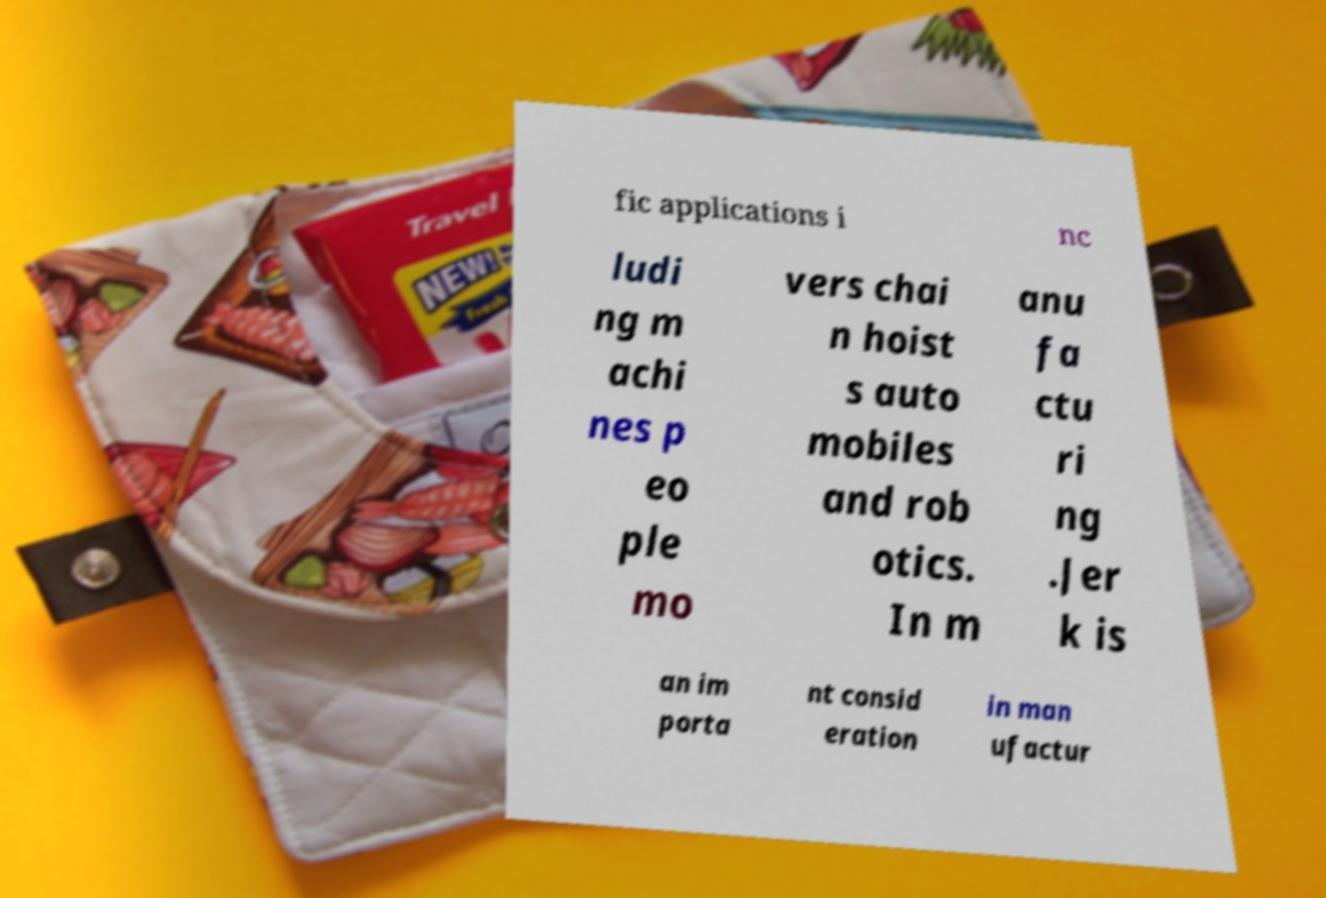For documentation purposes, I need the text within this image transcribed. Could you provide that? fic applications i nc ludi ng m achi nes p eo ple mo vers chai n hoist s auto mobiles and rob otics. In m anu fa ctu ri ng .Jer k is an im porta nt consid eration in man ufactur 